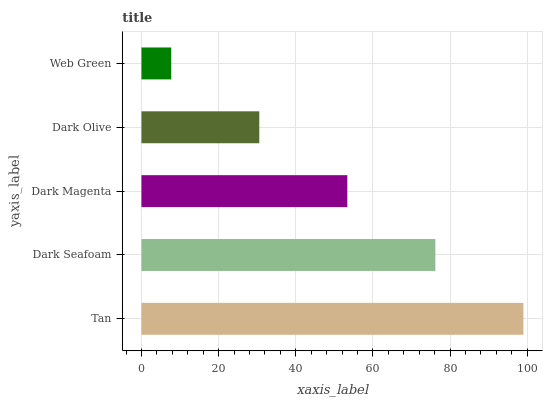Is Web Green the minimum?
Answer yes or no. Yes. Is Tan the maximum?
Answer yes or no. Yes. Is Dark Seafoam the minimum?
Answer yes or no. No. Is Dark Seafoam the maximum?
Answer yes or no. No. Is Tan greater than Dark Seafoam?
Answer yes or no. Yes. Is Dark Seafoam less than Tan?
Answer yes or no. Yes. Is Dark Seafoam greater than Tan?
Answer yes or no. No. Is Tan less than Dark Seafoam?
Answer yes or no. No. Is Dark Magenta the high median?
Answer yes or no. Yes. Is Dark Magenta the low median?
Answer yes or no. Yes. Is Tan the high median?
Answer yes or no. No. Is Web Green the low median?
Answer yes or no. No. 